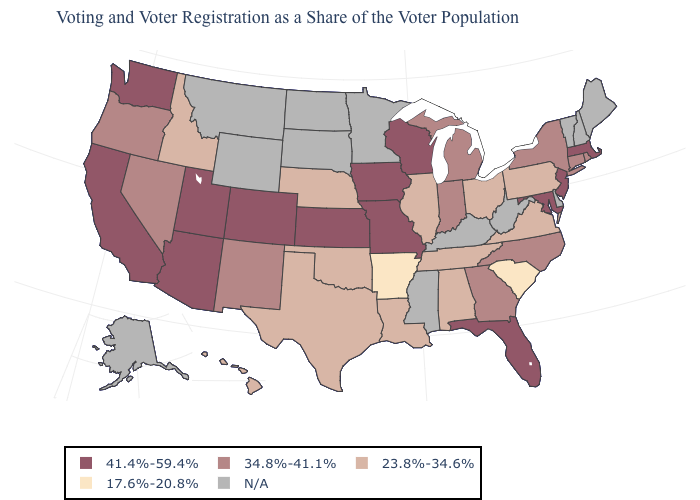Is the legend a continuous bar?
Keep it brief. No. What is the value of Texas?
Short answer required. 23.8%-34.6%. What is the value of South Dakota?
Be succinct. N/A. Name the states that have a value in the range 41.4%-59.4%?
Short answer required. Arizona, California, Colorado, Florida, Iowa, Kansas, Maryland, Massachusetts, Missouri, New Jersey, Utah, Washington, Wisconsin. Which states have the lowest value in the Northeast?
Be succinct. Pennsylvania. What is the lowest value in the South?
Give a very brief answer. 17.6%-20.8%. What is the lowest value in the USA?
Concise answer only. 17.6%-20.8%. What is the value of Ohio?
Quick response, please. 23.8%-34.6%. Does California have the lowest value in the West?
Short answer required. No. Among the states that border Kentucky , which have the highest value?
Write a very short answer. Missouri. Among the states that border Florida , which have the highest value?
Concise answer only. Georgia. What is the value of New York?
Short answer required. 34.8%-41.1%. What is the value of Montana?
Be succinct. N/A. Does the map have missing data?
Short answer required. Yes. 